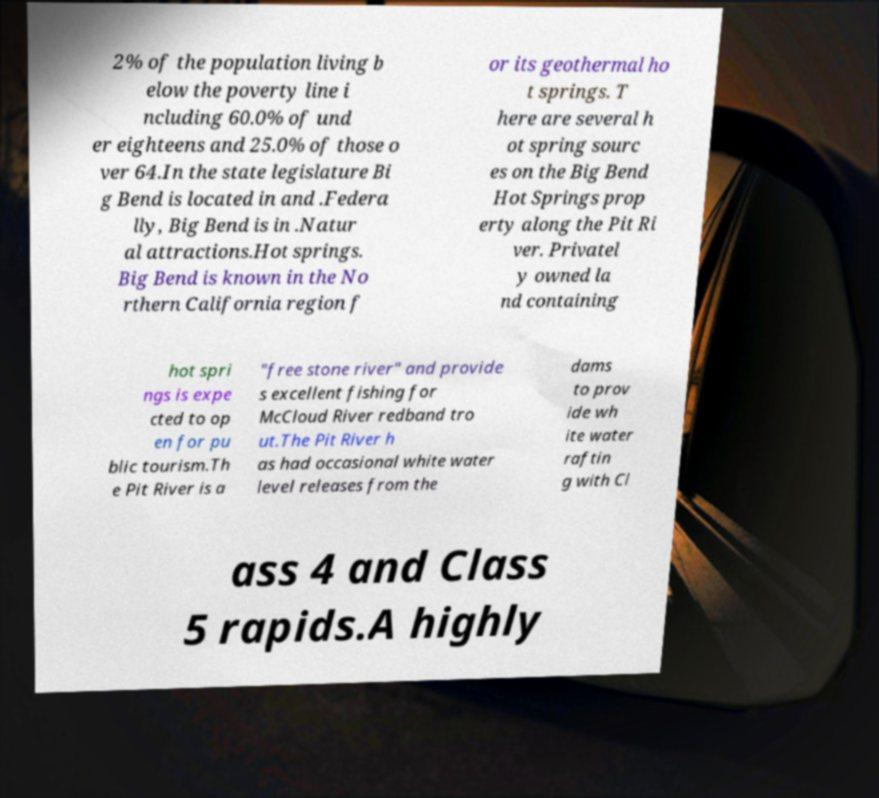Please identify and transcribe the text found in this image. 2% of the population living b elow the poverty line i ncluding 60.0% of und er eighteens and 25.0% of those o ver 64.In the state legislature Bi g Bend is located in and .Federa lly, Big Bend is in .Natur al attractions.Hot springs. Big Bend is known in the No rthern California region f or its geothermal ho t springs. T here are several h ot spring sourc es on the Big Bend Hot Springs prop erty along the Pit Ri ver. Privatel y owned la nd containing hot spri ngs is expe cted to op en for pu blic tourism.Th e Pit River is a "free stone river" and provide s excellent fishing for McCloud River redband tro ut.The Pit River h as had occasional white water level releases from the dams to prov ide wh ite water raftin g with Cl ass 4 and Class 5 rapids.A highly 